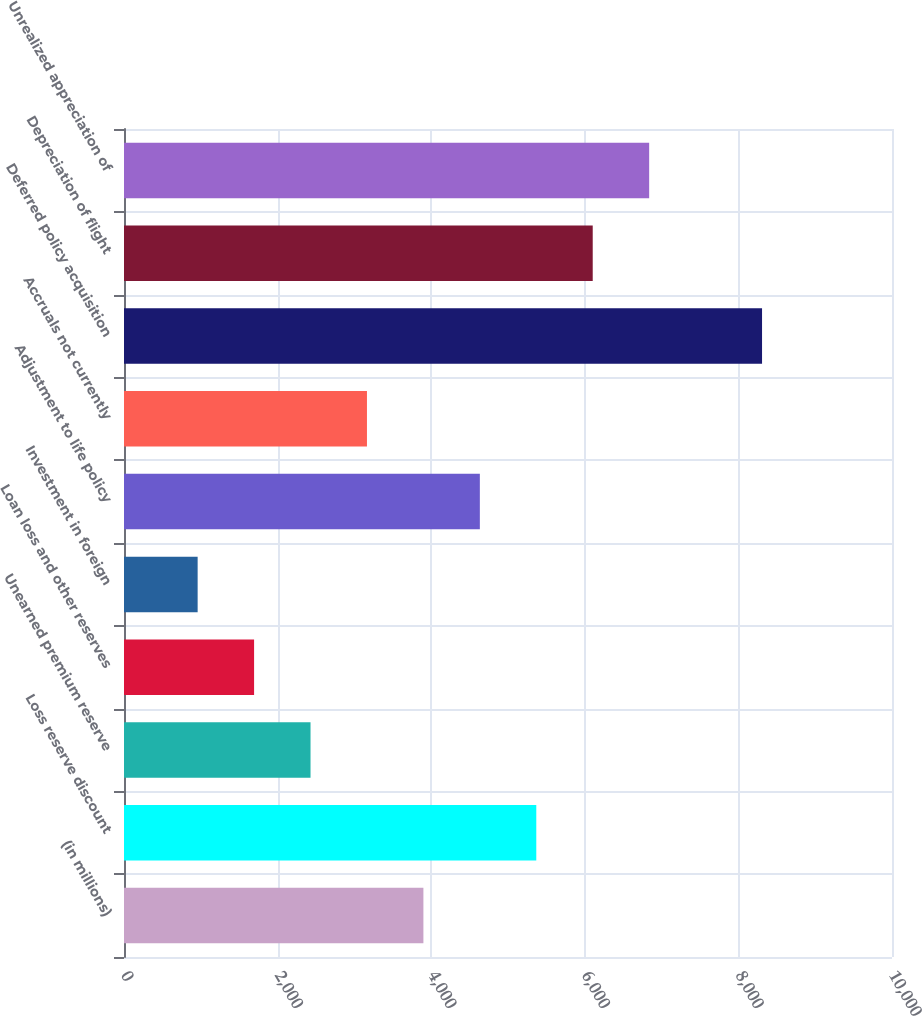Convert chart to OTSL. <chart><loc_0><loc_0><loc_500><loc_500><bar_chart><fcel>(in millions)<fcel>Loss reserve discount<fcel>Unearned premium reserve<fcel>Loan loss and other reserves<fcel>Investment in foreign<fcel>Adjustment to life policy<fcel>Accruals not currently<fcel>Deferred policy acquisition<fcel>Depreciation of flight<fcel>Unrealized appreciation of<nl><fcel>3898.5<fcel>5368.3<fcel>2428.7<fcel>1693.8<fcel>958.9<fcel>4633.4<fcel>3163.6<fcel>8307.9<fcel>6103.2<fcel>6838.1<nl></chart> 